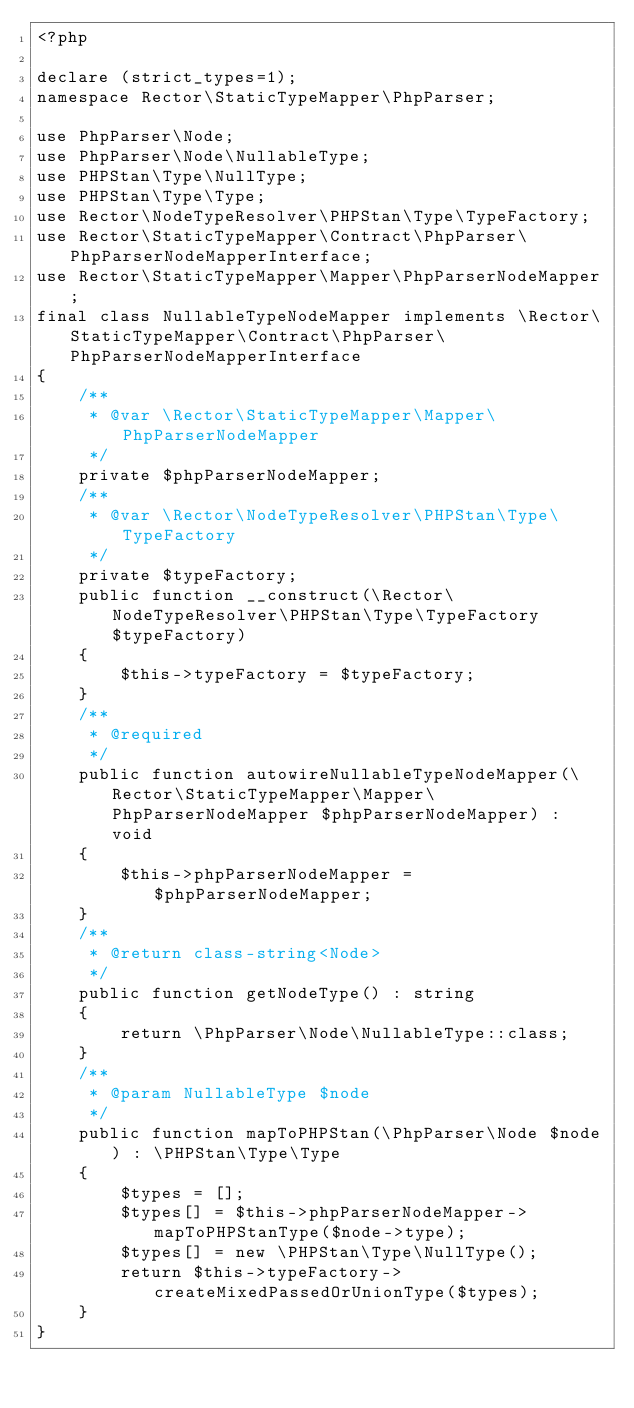Convert code to text. <code><loc_0><loc_0><loc_500><loc_500><_PHP_><?php

declare (strict_types=1);
namespace Rector\StaticTypeMapper\PhpParser;

use PhpParser\Node;
use PhpParser\Node\NullableType;
use PHPStan\Type\NullType;
use PHPStan\Type\Type;
use Rector\NodeTypeResolver\PHPStan\Type\TypeFactory;
use Rector\StaticTypeMapper\Contract\PhpParser\PhpParserNodeMapperInterface;
use Rector\StaticTypeMapper\Mapper\PhpParserNodeMapper;
final class NullableTypeNodeMapper implements \Rector\StaticTypeMapper\Contract\PhpParser\PhpParserNodeMapperInterface
{
    /**
     * @var \Rector\StaticTypeMapper\Mapper\PhpParserNodeMapper
     */
    private $phpParserNodeMapper;
    /**
     * @var \Rector\NodeTypeResolver\PHPStan\Type\TypeFactory
     */
    private $typeFactory;
    public function __construct(\Rector\NodeTypeResolver\PHPStan\Type\TypeFactory $typeFactory)
    {
        $this->typeFactory = $typeFactory;
    }
    /**
     * @required
     */
    public function autowireNullableTypeNodeMapper(\Rector\StaticTypeMapper\Mapper\PhpParserNodeMapper $phpParserNodeMapper) : void
    {
        $this->phpParserNodeMapper = $phpParserNodeMapper;
    }
    /**
     * @return class-string<Node>
     */
    public function getNodeType() : string
    {
        return \PhpParser\Node\NullableType::class;
    }
    /**
     * @param NullableType $node
     */
    public function mapToPHPStan(\PhpParser\Node $node) : \PHPStan\Type\Type
    {
        $types = [];
        $types[] = $this->phpParserNodeMapper->mapToPHPStanType($node->type);
        $types[] = new \PHPStan\Type\NullType();
        return $this->typeFactory->createMixedPassedOrUnionType($types);
    }
}
</code> 